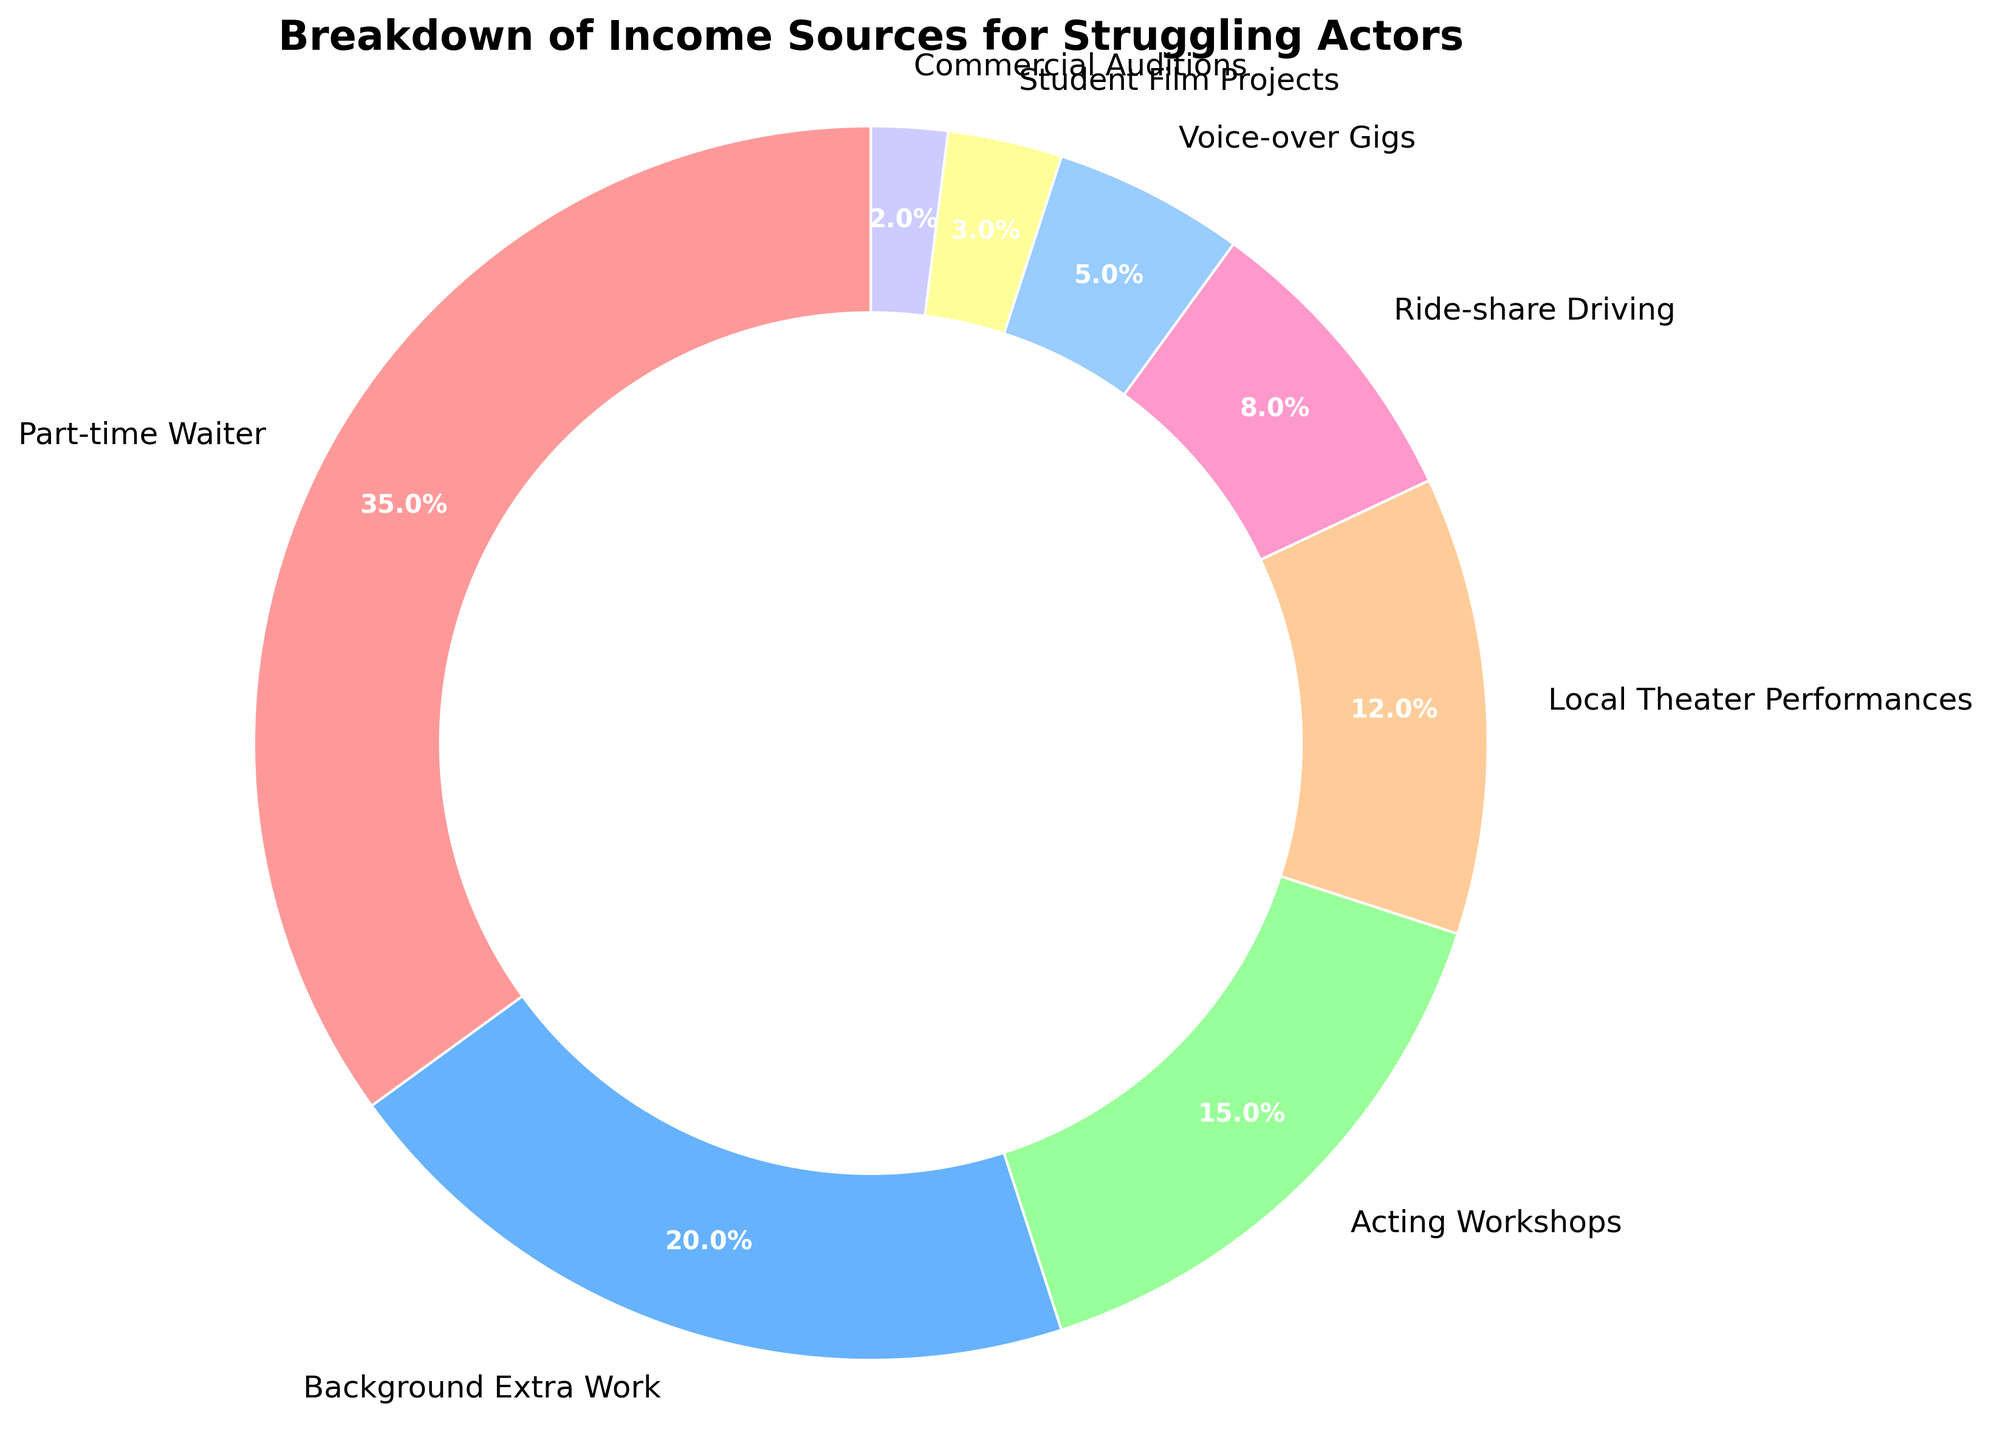Which income source contributes the most to a struggling actor's income? The largest slice in the pie chart represents the largest income source. This slice corresponds to 'Part-time Waiter' with 35%.
Answer: Part-time Waiter What's the total percentage of income from 'Background Extra Work' and 'Local Theater Performances'? Add the percentages of 'Background Extra Work' (20%) and 'Local Theater Performances' (12%). The sum is 20% + 12% = 32%.
Answer: 32% Which income source has the smallest percentage? The smallest slice in the pie chart corresponds to 'Commercial Auditions' with a percentage of 2%.
Answer: Commercial Auditions Is the percentage of income from 'Voice-over Gigs' greater than 'Student Film Projects'? Compare the two slices labeled 'Voice-over Gigs' (5%) and 'Student Film Projects' (3%). 5% is greater than 3%.
Answer: Yes What is the combined percentage of income from all sources except 'Part-time Waiter'? Subtract the 'Part-time Waiter' percentage (35%) from 100%. The calculation is 100% - 35% = 65%.
Answer: 65% Which income source is represented by the light blue color in the pie chart? The slice with the light blue color corresponds to the 'Background Extra Work' with 20%.
Answer: Background Extra Work What is the approximate difference in percentage between 'Acting Workshops' and 'Ride-share Driving'? Subtract the 'Ride-share Driving' percentage (8%) from 'Acting Workshops' (15%). The difference is 15% - 8% = 7%.
Answer: 7% Which two income sources combined make up exactly 20% of the income? The slices for 'Voice-over Gigs' (5%) and 'Student Film Projects' (3%) together do not make 20%. The first combination that sums up to 20% is 'Background Extra Work' (20%).
Answer: Background Extra Work How much more income percentage do 'Part-time Waiter' and 'Background Extra Work' combined contribute compared to 'Acting Workshops' and 'Local Theater Performances'? First, add the percentages of 'Part-time Waiter' (35%) and 'Background Extra Work' (20%) to get 55%. Then, add 'Acting Workshops' (15%) and 'Local Theater Performances' (12%) to get 27%. Finally, subtract the two sums: 55% - 27% = 28%.
Answer: 28% List the income sources which combined make up more than 50% of the income. Start by listing the sources in descending order: 'Part-time Waiter' (35%) + 'Background Extra Work' (20%) = 55%, which is more than 50%.
Answer: Part-time Waiter, Background Extra Work 